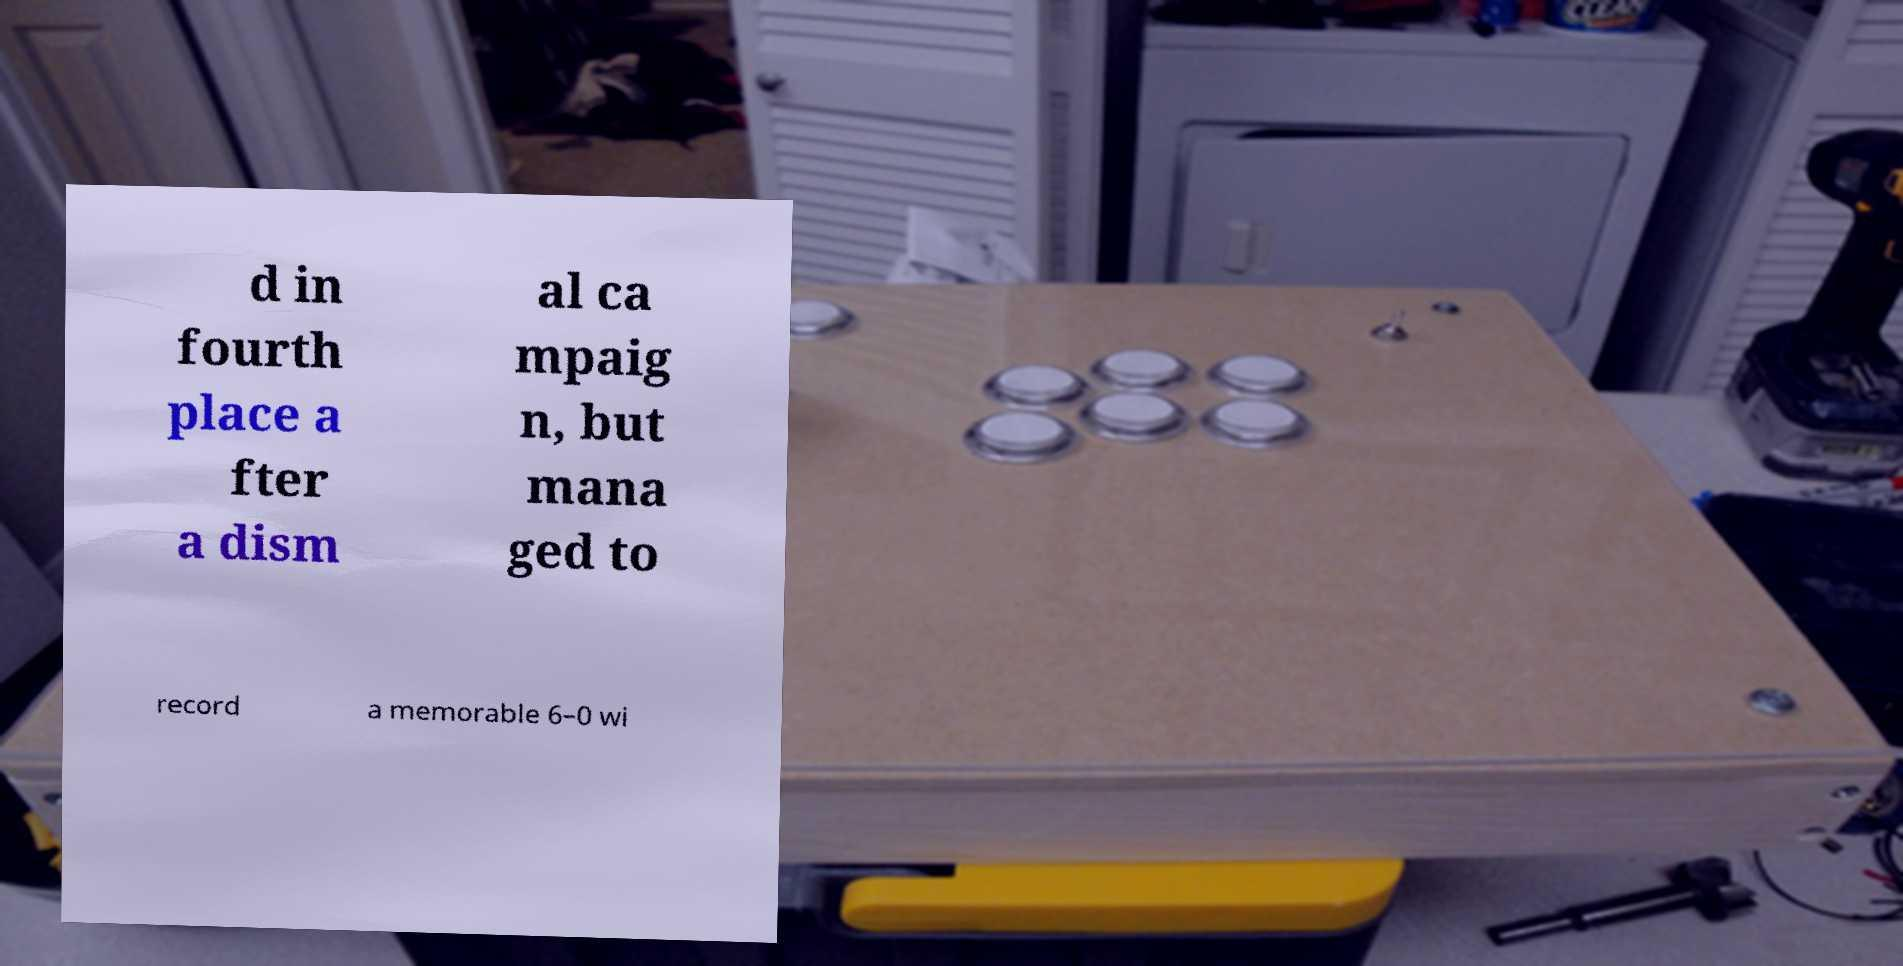Please identify and transcribe the text found in this image. d in fourth place a fter a dism al ca mpaig n, but mana ged to record a memorable 6–0 wi 